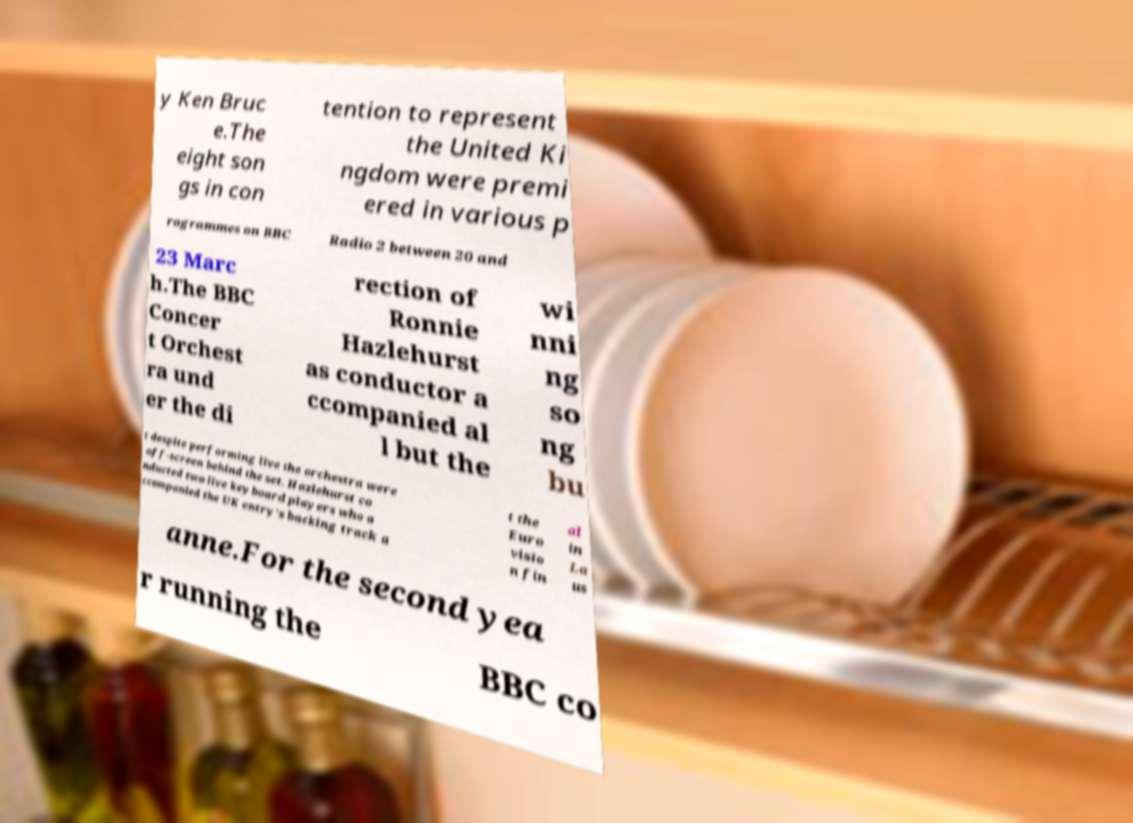Can you read and provide the text displayed in the image?This photo seems to have some interesting text. Can you extract and type it out for me? y Ken Bruc e.The eight son gs in con tention to represent the United Ki ngdom were premi ered in various p rogrammes on BBC Radio 2 between 20 and 23 Marc h.The BBC Concer t Orchest ra und er the di rection of Ronnie Hazlehurst as conductor a ccompanied al l but the wi nni ng so ng bu t despite performing live the orchestra were off-screen behind the set. Hazlehurst co nducted two live keyboard players who a ccompanied the UK entry’s backing track a t the Euro visio n fin al in La us anne.For the second yea r running the BBC co 